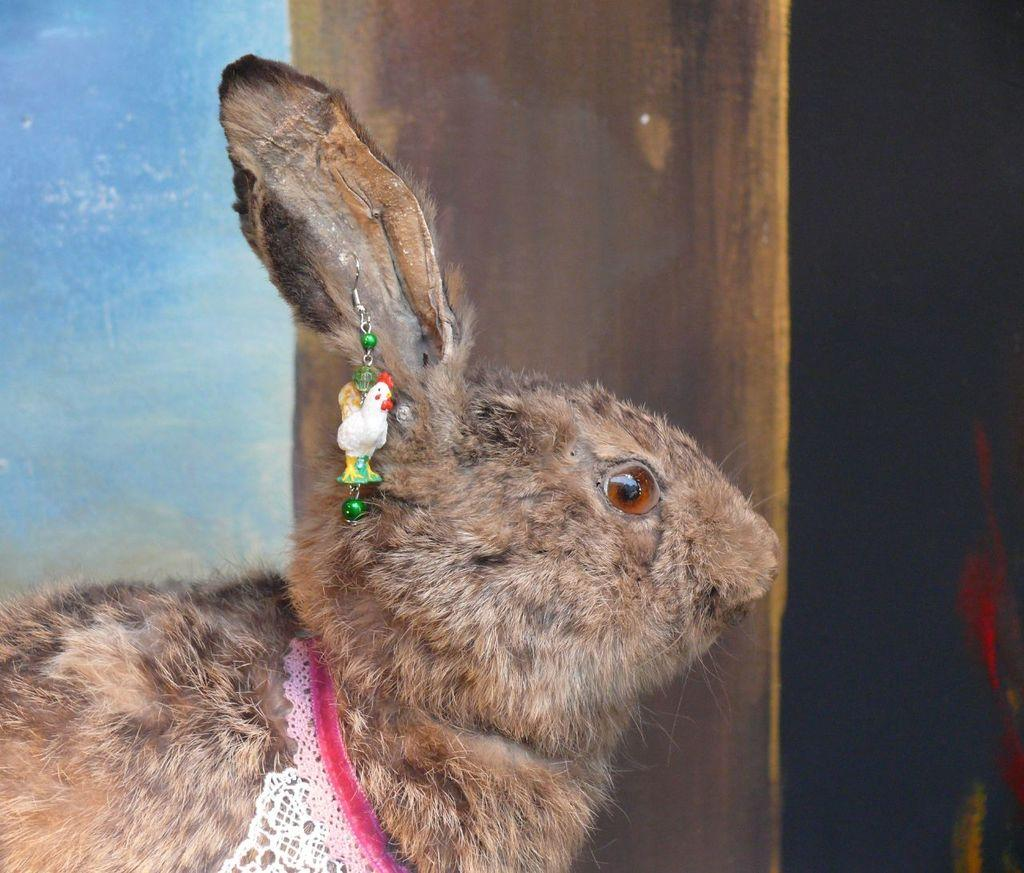What type of animal is present in the image? There is a brown color rabbit in the image. Reasoning: Let' Let's think step by step in order to produce the conversation. We start by identifying the main subject in the image, which is the brown color rabbit. Then, we formulate a question that focuses on the type of animal present in the image, ensuring that the answer can be derived directly from the provided fact. We avoid yes/no questions and ensure that the language is simple and clear. Absurd Question/Answer: What color is the powder that is sprinkled on the moon in the image? There is no powder or moon present in the image; it only features a brown color rabbit. What color is the vein that is visible on the moon in the image? There is no vein or moon present in the image; it only features a brown color rabbit. 